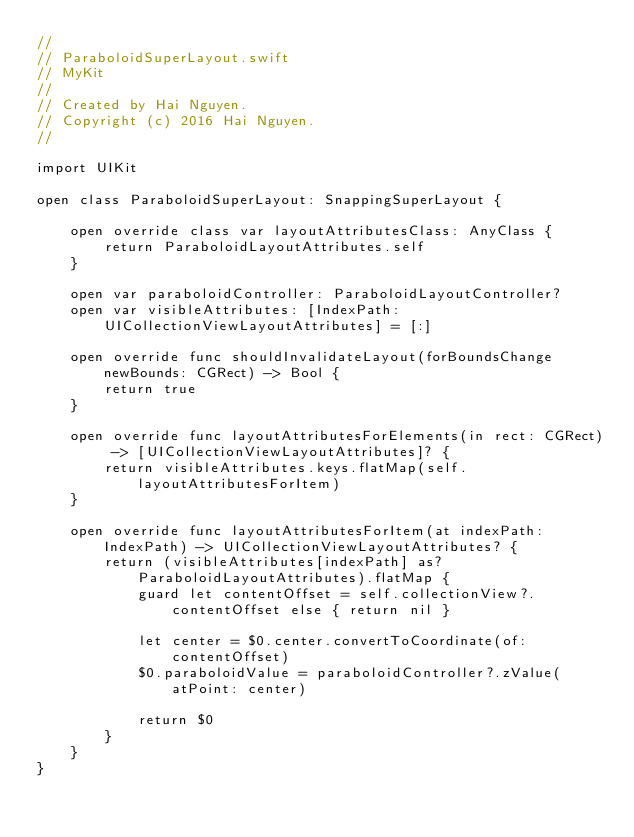Convert code to text. <code><loc_0><loc_0><loc_500><loc_500><_Swift_>// 
// ParaboloidSuperLayout.swift
// MyKit
// 
// Created by Hai Nguyen.
// Copyright (c) 2016 Hai Nguyen.
// 

import UIKit

open class ParaboloidSuperLayout: SnappingSuperLayout {

    open override class var layoutAttributesClass: AnyClass {
        return ParaboloidLayoutAttributes.self
    }

    open var paraboloidController: ParaboloidLayoutController?
    open var visibleAttributes: [IndexPath: UICollectionViewLayoutAttributes] = [:]

    open override func shouldInvalidateLayout(forBoundsChange newBounds: CGRect) -> Bool {
        return true
    }

    open override func layoutAttributesForElements(in rect: CGRect) -> [UICollectionViewLayoutAttributes]? {
        return visibleAttributes.keys.flatMap(self.layoutAttributesForItem)
    }

    open override func layoutAttributesForItem(at indexPath: IndexPath) -> UICollectionViewLayoutAttributes? {
        return (visibleAttributes[indexPath] as? ParaboloidLayoutAttributes).flatMap {
            guard let contentOffset = self.collectionView?.contentOffset else { return nil }

            let center = $0.center.convertToCoordinate(of: contentOffset)
            $0.paraboloidValue = paraboloidController?.zValue(atPoint: center)

            return $0
        }
    }
}
</code> 